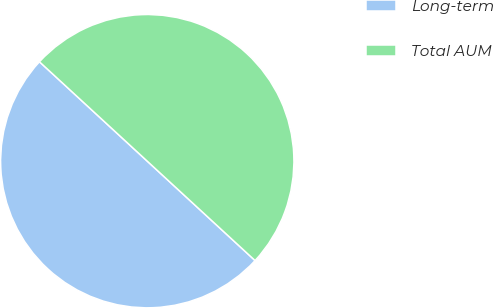Convert chart to OTSL. <chart><loc_0><loc_0><loc_500><loc_500><pie_chart><fcel>Long-term<fcel>Total AUM<nl><fcel>50.0%<fcel>50.0%<nl></chart> 